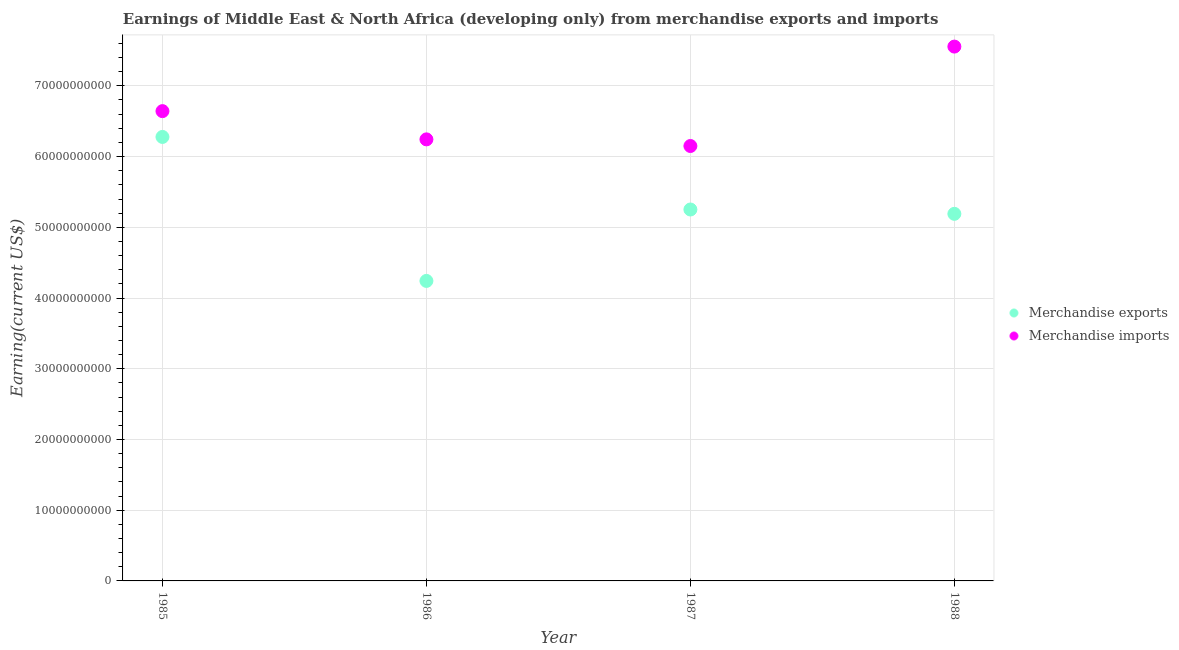What is the earnings from merchandise exports in 1985?
Give a very brief answer. 6.28e+1. Across all years, what is the maximum earnings from merchandise imports?
Give a very brief answer. 7.56e+1. Across all years, what is the minimum earnings from merchandise imports?
Provide a succinct answer. 6.15e+1. What is the total earnings from merchandise imports in the graph?
Offer a very short reply. 2.66e+11. What is the difference between the earnings from merchandise imports in 1985 and that in 1986?
Make the answer very short. 3.99e+09. What is the difference between the earnings from merchandise exports in 1987 and the earnings from merchandise imports in 1988?
Provide a succinct answer. -2.30e+1. What is the average earnings from merchandise imports per year?
Provide a succinct answer. 6.65e+1. In the year 1986, what is the difference between the earnings from merchandise imports and earnings from merchandise exports?
Provide a short and direct response. 2.00e+1. What is the ratio of the earnings from merchandise imports in 1987 to that in 1988?
Your response must be concise. 0.81. Is the earnings from merchandise exports in 1985 less than that in 1986?
Give a very brief answer. No. Is the difference between the earnings from merchandise imports in 1985 and 1987 greater than the difference between the earnings from merchandise exports in 1985 and 1987?
Your response must be concise. No. What is the difference between the highest and the second highest earnings from merchandise imports?
Your response must be concise. 9.13e+09. What is the difference between the highest and the lowest earnings from merchandise imports?
Your answer should be very brief. 1.41e+1. In how many years, is the earnings from merchandise exports greater than the average earnings from merchandise exports taken over all years?
Give a very brief answer. 2. Is the sum of the earnings from merchandise exports in 1986 and 1988 greater than the maximum earnings from merchandise imports across all years?
Provide a short and direct response. Yes. Does the earnings from merchandise exports monotonically increase over the years?
Make the answer very short. No. Is the earnings from merchandise exports strictly greater than the earnings from merchandise imports over the years?
Offer a very short reply. No. Is the earnings from merchandise imports strictly less than the earnings from merchandise exports over the years?
Your answer should be very brief. No. How many dotlines are there?
Your answer should be compact. 2. How many years are there in the graph?
Give a very brief answer. 4. How many legend labels are there?
Ensure brevity in your answer.  2. What is the title of the graph?
Keep it short and to the point. Earnings of Middle East & North Africa (developing only) from merchandise exports and imports. Does "Highest 20% of population" appear as one of the legend labels in the graph?
Offer a very short reply. No. What is the label or title of the X-axis?
Ensure brevity in your answer.  Year. What is the label or title of the Y-axis?
Your answer should be very brief. Earning(current US$). What is the Earning(current US$) in Merchandise exports in 1985?
Provide a succinct answer. 6.28e+1. What is the Earning(current US$) in Merchandise imports in 1985?
Give a very brief answer. 6.64e+1. What is the Earning(current US$) in Merchandise exports in 1986?
Your answer should be very brief. 4.24e+1. What is the Earning(current US$) in Merchandise imports in 1986?
Keep it short and to the point. 6.24e+1. What is the Earning(current US$) in Merchandise exports in 1987?
Offer a very short reply. 5.25e+1. What is the Earning(current US$) in Merchandise imports in 1987?
Keep it short and to the point. 6.15e+1. What is the Earning(current US$) in Merchandise exports in 1988?
Keep it short and to the point. 5.19e+1. What is the Earning(current US$) of Merchandise imports in 1988?
Your answer should be very brief. 7.56e+1. Across all years, what is the maximum Earning(current US$) in Merchandise exports?
Ensure brevity in your answer.  6.28e+1. Across all years, what is the maximum Earning(current US$) of Merchandise imports?
Offer a terse response. 7.56e+1. Across all years, what is the minimum Earning(current US$) in Merchandise exports?
Provide a succinct answer. 4.24e+1. Across all years, what is the minimum Earning(current US$) in Merchandise imports?
Give a very brief answer. 6.15e+1. What is the total Earning(current US$) of Merchandise exports in the graph?
Your response must be concise. 2.10e+11. What is the total Earning(current US$) in Merchandise imports in the graph?
Your answer should be very brief. 2.66e+11. What is the difference between the Earning(current US$) in Merchandise exports in 1985 and that in 1986?
Your response must be concise. 2.04e+1. What is the difference between the Earning(current US$) in Merchandise imports in 1985 and that in 1986?
Make the answer very short. 3.99e+09. What is the difference between the Earning(current US$) in Merchandise exports in 1985 and that in 1987?
Your answer should be compact. 1.03e+1. What is the difference between the Earning(current US$) in Merchandise imports in 1985 and that in 1987?
Ensure brevity in your answer.  4.93e+09. What is the difference between the Earning(current US$) of Merchandise exports in 1985 and that in 1988?
Your answer should be very brief. 1.09e+1. What is the difference between the Earning(current US$) of Merchandise imports in 1985 and that in 1988?
Ensure brevity in your answer.  -9.13e+09. What is the difference between the Earning(current US$) in Merchandise exports in 1986 and that in 1987?
Your answer should be very brief. -1.01e+1. What is the difference between the Earning(current US$) of Merchandise imports in 1986 and that in 1987?
Your answer should be very brief. 9.37e+08. What is the difference between the Earning(current US$) of Merchandise exports in 1986 and that in 1988?
Offer a very short reply. -9.49e+09. What is the difference between the Earning(current US$) of Merchandise imports in 1986 and that in 1988?
Keep it short and to the point. -1.31e+1. What is the difference between the Earning(current US$) in Merchandise exports in 1987 and that in 1988?
Provide a succinct answer. 6.13e+08. What is the difference between the Earning(current US$) of Merchandise imports in 1987 and that in 1988?
Offer a very short reply. -1.41e+1. What is the difference between the Earning(current US$) of Merchandise exports in 1985 and the Earning(current US$) of Merchandise imports in 1986?
Offer a terse response. 3.44e+08. What is the difference between the Earning(current US$) in Merchandise exports in 1985 and the Earning(current US$) in Merchandise imports in 1987?
Your answer should be very brief. 1.28e+09. What is the difference between the Earning(current US$) in Merchandise exports in 1985 and the Earning(current US$) in Merchandise imports in 1988?
Your answer should be very brief. -1.28e+1. What is the difference between the Earning(current US$) of Merchandise exports in 1986 and the Earning(current US$) of Merchandise imports in 1987?
Your answer should be very brief. -1.91e+1. What is the difference between the Earning(current US$) in Merchandise exports in 1986 and the Earning(current US$) in Merchandise imports in 1988?
Your answer should be very brief. -3.31e+1. What is the difference between the Earning(current US$) of Merchandise exports in 1987 and the Earning(current US$) of Merchandise imports in 1988?
Your answer should be compact. -2.30e+1. What is the average Earning(current US$) in Merchandise exports per year?
Make the answer very short. 5.24e+1. What is the average Earning(current US$) in Merchandise imports per year?
Give a very brief answer. 6.65e+1. In the year 1985, what is the difference between the Earning(current US$) of Merchandise exports and Earning(current US$) of Merchandise imports?
Provide a short and direct response. -3.65e+09. In the year 1986, what is the difference between the Earning(current US$) of Merchandise exports and Earning(current US$) of Merchandise imports?
Offer a terse response. -2.00e+1. In the year 1987, what is the difference between the Earning(current US$) in Merchandise exports and Earning(current US$) in Merchandise imports?
Keep it short and to the point. -8.98e+09. In the year 1988, what is the difference between the Earning(current US$) of Merchandise exports and Earning(current US$) of Merchandise imports?
Your answer should be compact. -2.36e+1. What is the ratio of the Earning(current US$) in Merchandise exports in 1985 to that in 1986?
Provide a succinct answer. 1.48. What is the ratio of the Earning(current US$) in Merchandise imports in 1985 to that in 1986?
Offer a very short reply. 1.06. What is the ratio of the Earning(current US$) of Merchandise exports in 1985 to that in 1987?
Your response must be concise. 1.2. What is the ratio of the Earning(current US$) of Merchandise imports in 1985 to that in 1987?
Make the answer very short. 1.08. What is the ratio of the Earning(current US$) in Merchandise exports in 1985 to that in 1988?
Keep it short and to the point. 1.21. What is the ratio of the Earning(current US$) of Merchandise imports in 1985 to that in 1988?
Give a very brief answer. 0.88. What is the ratio of the Earning(current US$) in Merchandise exports in 1986 to that in 1987?
Offer a very short reply. 0.81. What is the ratio of the Earning(current US$) of Merchandise imports in 1986 to that in 1987?
Ensure brevity in your answer.  1.02. What is the ratio of the Earning(current US$) of Merchandise exports in 1986 to that in 1988?
Make the answer very short. 0.82. What is the ratio of the Earning(current US$) in Merchandise imports in 1986 to that in 1988?
Give a very brief answer. 0.83. What is the ratio of the Earning(current US$) of Merchandise exports in 1987 to that in 1988?
Your answer should be very brief. 1.01. What is the ratio of the Earning(current US$) of Merchandise imports in 1987 to that in 1988?
Your answer should be very brief. 0.81. What is the difference between the highest and the second highest Earning(current US$) in Merchandise exports?
Your response must be concise. 1.03e+1. What is the difference between the highest and the second highest Earning(current US$) of Merchandise imports?
Give a very brief answer. 9.13e+09. What is the difference between the highest and the lowest Earning(current US$) of Merchandise exports?
Make the answer very short. 2.04e+1. What is the difference between the highest and the lowest Earning(current US$) of Merchandise imports?
Offer a very short reply. 1.41e+1. 